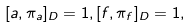<formula> <loc_0><loc_0><loc_500><loc_500>[ a , \pi _ { a } ] _ { D } = 1 , [ f , \pi _ { f } ] _ { D } = 1 ,</formula> 